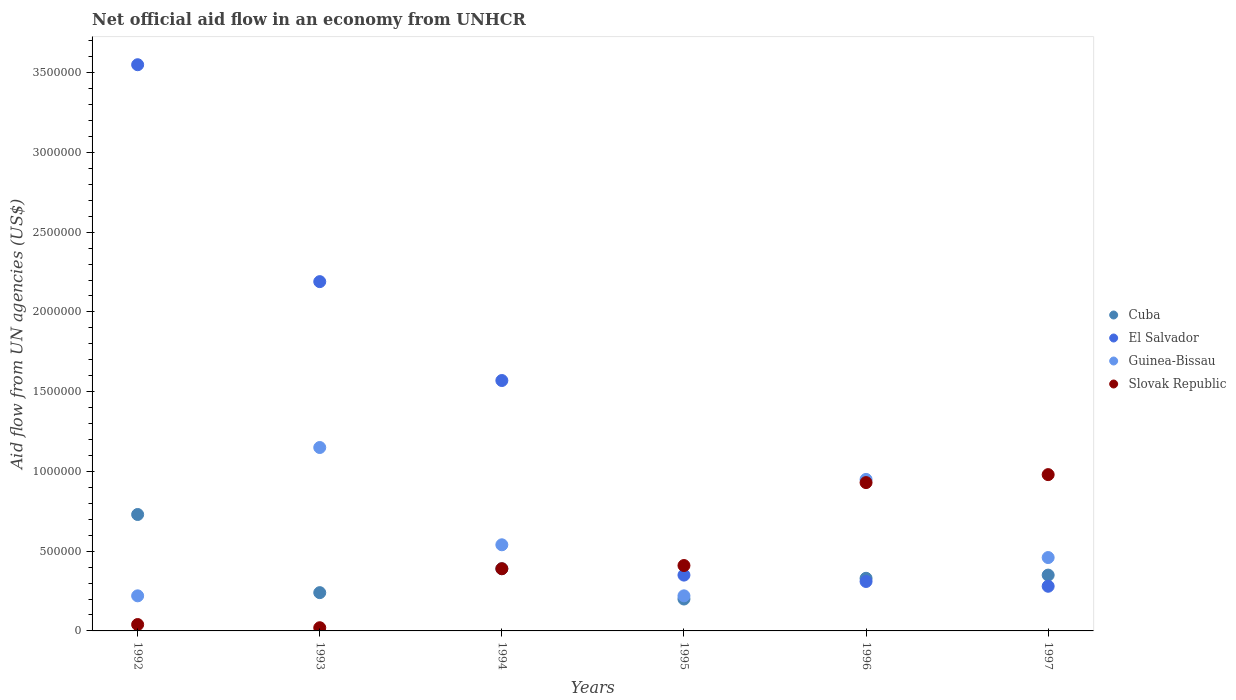Across all years, what is the maximum net official aid flow in Slovak Republic?
Offer a terse response. 9.80e+05. What is the total net official aid flow in Slovak Republic in the graph?
Your answer should be compact. 2.77e+06. What is the difference between the net official aid flow in Guinea-Bissau in 1992 and the net official aid flow in El Salvador in 1997?
Keep it short and to the point. -6.00e+04. What is the average net official aid flow in El Salvador per year?
Offer a very short reply. 1.38e+06. In the year 1994, what is the difference between the net official aid flow in Cuba and net official aid flow in El Salvador?
Offer a very short reply. -1.18e+06. In how many years, is the net official aid flow in El Salvador greater than 3300000 US$?
Keep it short and to the point. 1. What is the ratio of the net official aid flow in Guinea-Bissau in 1992 to that in 1996?
Provide a short and direct response. 0.23. What is the difference between the highest and the lowest net official aid flow in Cuba?
Provide a short and direct response. 5.30e+05. Does the net official aid flow in Guinea-Bissau monotonically increase over the years?
Offer a terse response. No. Is the net official aid flow in Slovak Republic strictly less than the net official aid flow in Guinea-Bissau over the years?
Your answer should be very brief. No. How many years are there in the graph?
Make the answer very short. 6. Are the values on the major ticks of Y-axis written in scientific E-notation?
Keep it short and to the point. No. Does the graph contain any zero values?
Offer a terse response. No. Where does the legend appear in the graph?
Your response must be concise. Center right. How many legend labels are there?
Your response must be concise. 4. What is the title of the graph?
Ensure brevity in your answer.  Net official aid flow in an economy from UNHCR. Does "Central African Republic" appear as one of the legend labels in the graph?
Offer a very short reply. No. What is the label or title of the Y-axis?
Keep it short and to the point. Aid flow from UN agencies (US$). What is the Aid flow from UN agencies (US$) of Cuba in 1992?
Ensure brevity in your answer.  7.30e+05. What is the Aid flow from UN agencies (US$) of El Salvador in 1992?
Your response must be concise. 3.55e+06. What is the Aid flow from UN agencies (US$) in Guinea-Bissau in 1992?
Give a very brief answer. 2.20e+05. What is the Aid flow from UN agencies (US$) of Slovak Republic in 1992?
Offer a very short reply. 4.00e+04. What is the Aid flow from UN agencies (US$) of El Salvador in 1993?
Your response must be concise. 2.19e+06. What is the Aid flow from UN agencies (US$) in Guinea-Bissau in 1993?
Provide a short and direct response. 1.15e+06. What is the Aid flow from UN agencies (US$) of El Salvador in 1994?
Keep it short and to the point. 1.57e+06. What is the Aid flow from UN agencies (US$) of Guinea-Bissau in 1994?
Provide a short and direct response. 5.40e+05. What is the Aid flow from UN agencies (US$) in Slovak Republic in 1994?
Your answer should be compact. 3.90e+05. What is the Aid flow from UN agencies (US$) in Guinea-Bissau in 1995?
Your answer should be very brief. 2.20e+05. What is the Aid flow from UN agencies (US$) of Guinea-Bissau in 1996?
Provide a succinct answer. 9.50e+05. What is the Aid flow from UN agencies (US$) in Slovak Republic in 1996?
Your answer should be compact. 9.30e+05. What is the Aid flow from UN agencies (US$) of Cuba in 1997?
Your response must be concise. 3.50e+05. What is the Aid flow from UN agencies (US$) in El Salvador in 1997?
Your response must be concise. 2.80e+05. What is the Aid flow from UN agencies (US$) of Slovak Republic in 1997?
Your response must be concise. 9.80e+05. Across all years, what is the maximum Aid flow from UN agencies (US$) of Cuba?
Offer a terse response. 7.30e+05. Across all years, what is the maximum Aid flow from UN agencies (US$) of El Salvador?
Offer a terse response. 3.55e+06. Across all years, what is the maximum Aid flow from UN agencies (US$) of Guinea-Bissau?
Your answer should be compact. 1.15e+06. Across all years, what is the maximum Aid flow from UN agencies (US$) in Slovak Republic?
Offer a very short reply. 9.80e+05. Across all years, what is the minimum Aid flow from UN agencies (US$) in Cuba?
Your response must be concise. 2.00e+05. Across all years, what is the minimum Aid flow from UN agencies (US$) of Slovak Republic?
Offer a very short reply. 2.00e+04. What is the total Aid flow from UN agencies (US$) in Cuba in the graph?
Offer a very short reply. 2.24e+06. What is the total Aid flow from UN agencies (US$) of El Salvador in the graph?
Give a very brief answer. 8.25e+06. What is the total Aid flow from UN agencies (US$) in Guinea-Bissau in the graph?
Provide a succinct answer. 3.54e+06. What is the total Aid flow from UN agencies (US$) in Slovak Republic in the graph?
Provide a short and direct response. 2.77e+06. What is the difference between the Aid flow from UN agencies (US$) of Cuba in 1992 and that in 1993?
Your answer should be compact. 4.90e+05. What is the difference between the Aid flow from UN agencies (US$) of El Salvador in 1992 and that in 1993?
Provide a succinct answer. 1.36e+06. What is the difference between the Aid flow from UN agencies (US$) of Guinea-Bissau in 1992 and that in 1993?
Offer a very short reply. -9.30e+05. What is the difference between the Aid flow from UN agencies (US$) of Slovak Republic in 1992 and that in 1993?
Your response must be concise. 2.00e+04. What is the difference between the Aid flow from UN agencies (US$) in Cuba in 1992 and that in 1994?
Offer a very short reply. 3.40e+05. What is the difference between the Aid flow from UN agencies (US$) of El Salvador in 1992 and that in 1994?
Offer a terse response. 1.98e+06. What is the difference between the Aid flow from UN agencies (US$) in Guinea-Bissau in 1992 and that in 1994?
Provide a succinct answer. -3.20e+05. What is the difference between the Aid flow from UN agencies (US$) in Slovak Republic in 1992 and that in 1994?
Make the answer very short. -3.50e+05. What is the difference between the Aid flow from UN agencies (US$) of Cuba in 1992 and that in 1995?
Offer a terse response. 5.30e+05. What is the difference between the Aid flow from UN agencies (US$) in El Salvador in 1992 and that in 1995?
Your answer should be very brief. 3.20e+06. What is the difference between the Aid flow from UN agencies (US$) of Guinea-Bissau in 1992 and that in 1995?
Provide a succinct answer. 0. What is the difference between the Aid flow from UN agencies (US$) in Slovak Republic in 1992 and that in 1995?
Make the answer very short. -3.70e+05. What is the difference between the Aid flow from UN agencies (US$) in El Salvador in 1992 and that in 1996?
Make the answer very short. 3.24e+06. What is the difference between the Aid flow from UN agencies (US$) in Guinea-Bissau in 1992 and that in 1996?
Your response must be concise. -7.30e+05. What is the difference between the Aid flow from UN agencies (US$) of Slovak Republic in 1992 and that in 1996?
Provide a succinct answer. -8.90e+05. What is the difference between the Aid flow from UN agencies (US$) in El Salvador in 1992 and that in 1997?
Your response must be concise. 3.27e+06. What is the difference between the Aid flow from UN agencies (US$) of Guinea-Bissau in 1992 and that in 1997?
Offer a terse response. -2.40e+05. What is the difference between the Aid flow from UN agencies (US$) of Slovak Republic in 1992 and that in 1997?
Offer a terse response. -9.40e+05. What is the difference between the Aid flow from UN agencies (US$) of El Salvador in 1993 and that in 1994?
Provide a succinct answer. 6.20e+05. What is the difference between the Aid flow from UN agencies (US$) in Slovak Republic in 1993 and that in 1994?
Your answer should be compact. -3.70e+05. What is the difference between the Aid flow from UN agencies (US$) in Cuba in 1993 and that in 1995?
Your answer should be compact. 4.00e+04. What is the difference between the Aid flow from UN agencies (US$) of El Salvador in 1993 and that in 1995?
Ensure brevity in your answer.  1.84e+06. What is the difference between the Aid flow from UN agencies (US$) of Guinea-Bissau in 1993 and that in 1995?
Ensure brevity in your answer.  9.30e+05. What is the difference between the Aid flow from UN agencies (US$) in Slovak Republic in 1993 and that in 1995?
Give a very brief answer. -3.90e+05. What is the difference between the Aid flow from UN agencies (US$) of El Salvador in 1993 and that in 1996?
Give a very brief answer. 1.88e+06. What is the difference between the Aid flow from UN agencies (US$) in Slovak Republic in 1993 and that in 1996?
Provide a short and direct response. -9.10e+05. What is the difference between the Aid flow from UN agencies (US$) in El Salvador in 1993 and that in 1997?
Offer a very short reply. 1.91e+06. What is the difference between the Aid flow from UN agencies (US$) of Guinea-Bissau in 1993 and that in 1997?
Your response must be concise. 6.90e+05. What is the difference between the Aid flow from UN agencies (US$) of Slovak Republic in 1993 and that in 1997?
Ensure brevity in your answer.  -9.60e+05. What is the difference between the Aid flow from UN agencies (US$) of Cuba in 1994 and that in 1995?
Offer a terse response. 1.90e+05. What is the difference between the Aid flow from UN agencies (US$) in El Salvador in 1994 and that in 1995?
Give a very brief answer. 1.22e+06. What is the difference between the Aid flow from UN agencies (US$) in Guinea-Bissau in 1994 and that in 1995?
Provide a short and direct response. 3.20e+05. What is the difference between the Aid flow from UN agencies (US$) in Slovak Republic in 1994 and that in 1995?
Make the answer very short. -2.00e+04. What is the difference between the Aid flow from UN agencies (US$) in Cuba in 1994 and that in 1996?
Your answer should be very brief. 6.00e+04. What is the difference between the Aid flow from UN agencies (US$) of El Salvador in 1994 and that in 1996?
Your answer should be compact. 1.26e+06. What is the difference between the Aid flow from UN agencies (US$) of Guinea-Bissau in 1994 and that in 1996?
Keep it short and to the point. -4.10e+05. What is the difference between the Aid flow from UN agencies (US$) of Slovak Republic in 1994 and that in 1996?
Your answer should be compact. -5.40e+05. What is the difference between the Aid flow from UN agencies (US$) of El Salvador in 1994 and that in 1997?
Provide a short and direct response. 1.29e+06. What is the difference between the Aid flow from UN agencies (US$) of Guinea-Bissau in 1994 and that in 1997?
Offer a very short reply. 8.00e+04. What is the difference between the Aid flow from UN agencies (US$) in Slovak Republic in 1994 and that in 1997?
Provide a succinct answer. -5.90e+05. What is the difference between the Aid flow from UN agencies (US$) in Guinea-Bissau in 1995 and that in 1996?
Provide a succinct answer. -7.30e+05. What is the difference between the Aid flow from UN agencies (US$) of Slovak Republic in 1995 and that in 1996?
Offer a very short reply. -5.20e+05. What is the difference between the Aid flow from UN agencies (US$) in Cuba in 1995 and that in 1997?
Your answer should be compact. -1.50e+05. What is the difference between the Aid flow from UN agencies (US$) of Slovak Republic in 1995 and that in 1997?
Keep it short and to the point. -5.70e+05. What is the difference between the Aid flow from UN agencies (US$) of El Salvador in 1996 and that in 1997?
Your answer should be compact. 3.00e+04. What is the difference between the Aid flow from UN agencies (US$) in Cuba in 1992 and the Aid flow from UN agencies (US$) in El Salvador in 1993?
Keep it short and to the point. -1.46e+06. What is the difference between the Aid flow from UN agencies (US$) of Cuba in 1992 and the Aid flow from UN agencies (US$) of Guinea-Bissau in 1993?
Keep it short and to the point. -4.20e+05. What is the difference between the Aid flow from UN agencies (US$) of Cuba in 1992 and the Aid flow from UN agencies (US$) of Slovak Republic in 1993?
Make the answer very short. 7.10e+05. What is the difference between the Aid flow from UN agencies (US$) in El Salvador in 1992 and the Aid flow from UN agencies (US$) in Guinea-Bissau in 1993?
Your answer should be compact. 2.40e+06. What is the difference between the Aid flow from UN agencies (US$) of El Salvador in 1992 and the Aid flow from UN agencies (US$) of Slovak Republic in 1993?
Offer a terse response. 3.53e+06. What is the difference between the Aid flow from UN agencies (US$) in Guinea-Bissau in 1992 and the Aid flow from UN agencies (US$) in Slovak Republic in 1993?
Your answer should be very brief. 2.00e+05. What is the difference between the Aid flow from UN agencies (US$) of Cuba in 1992 and the Aid flow from UN agencies (US$) of El Salvador in 1994?
Your answer should be compact. -8.40e+05. What is the difference between the Aid flow from UN agencies (US$) of Cuba in 1992 and the Aid flow from UN agencies (US$) of Guinea-Bissau in 1994?
Make the answer very short. 1.90e+05. What is the difference between the Aid flow from UN agencies (US$) in Cuba in 1992 and the Aid flow from UN agencies (US$) in Slovak Republic in 1994?
Your answer should be very brief. 3.40e+05. What is the difference between the Aid flow from UN agencies (US$) in El Salvador in 1992 and the Aid flow from UN agencies (US$) in Guinea-Bissau in 1994?
Offer a terse response. 3.01e+06. What is the difference between the Aid flow from UN agencies (US$) in El Salvador in 1992 and the Aid flow from UN agencies (US$) in Slovak Republic in 1994?
Provide a succinct answer. 3.16e+06. What is the difference between the Aid flow from UN agencies (US$) of Cuba in 1992 and the Aid flow from UN agencies (US$) of Guinea-Bissau in 1995?
Your answer should be compact. 5.10e+05. What is the difference between the Aid flow from UN agencies (US$) of El Salvador in 1992 and the Aid flow from UN agencies (US$) of Guinea-Bissau in 1995?
Ensure brevity in your answer.  3.33e+06. What is the difference between the Aid flow from UN agencies (US$) in El Salvador in 1992 and the Aid flow from UN agencies (US$) in Slovak Republic in 1995?
Make the answer very short. 3.14e+06. What is the difference between the Aid flow from UN agencies (US$) in Cuba in 1992 and the Aid flow from UN agencies (US$) in Guinea-Bissau in 1996?
Ensure brevity in your answer.  -2.20e+05. What is the difference between the Aid flow from UN agencies (US$) of Cuba in 1992 and the Aid flow from UN agencies (US$) of Slovak Republic in 1996?
Your answer should be compact. -2.00e+05. What is the difference between the Aid flow from UN agencies (US$) in El Salvador in 1992 and the Aid flow from UN agencies (US$) in Guinea-Bissau in 1996?
Provide a succinct answer. 2.60e+06. What is the difference between the Aid flow from UN agencies (US$) of El Salvador in 1992 and the Aid flow from UN agencies (US$) of Slovak Republic in 1996?
Offer a very short reply. 2.62e+06. What is the difference between the Aid flow from UN agencies (US$) in Guinea-Bissau in 1992 and the Aid flow from UN agencies (US$) in Slovak Republic in 1996?
Provide a short and direct response. -7.10e+05. What is the difference between the Aid flow from UN agencies (US$) of Cuba in 1992 and the Aid flow from UN agencies (US$) of El Salvador in 1997?
Your answer should be very brief. 4.50e+05. What is the difference between the Aid flow from UN agencies (US$) in Cuba in 1992 and the Aid flow from UN agencies (US$) in Guinea-Bissau in 1997?
Offer a terse response. 2.70e+05. What is the difference between the Aid flow from UN agencies (US$) in El Salvador in 1992 and the Aid flow from UN agencies (US$) in Guinea-Bissau in 1997?
Make the answer very short. 3.09e+06. What is the difference between the Aid flow from UN agencies (US$) in El Salvador in 1992 and the Aid flow from UN agencies (US$) in Slovak Republic in 1997?
Offer a very short reply. 2.57e+06. What is the difference between the Aid flow from UN agencies (US$) of Guinea-Bissau in 1992 and the Aid flow from UN agencies (US$) of Slovak Republic in 1997?
Keep it short and to the point. -7.60e+05. What is the difference between the Aid flow from UN agencies (US$) in Cuba in 1993 and the Aid flow from UN agencies (US$) in El Salvador in 1994?
Provide a succinct answer. -1.33e+06. What is the difference between the Aid flow from UN agencies (US$) in Cuba in 1993 and the Aid flow from UN agencies (US$) in Guinea-Bissau in 1994?
Ensure brevity in your answer.  -3.00e+05. What is the difference between the Aid flow from UN agencies (US$) of El Salvador in 1993 and the Aid flow from UN agencies (US$) of Guinea-Bissau in 1994?
Keep it short and to the point. 1.65e+06. What is the difference between the Aid flow from UN agencies (US$) in El Salvador in 1993 and the Aid flow from UN agencies (US$) in Slovak Republic in 1994?
Ensure brevity in your answer.  1.80e+06. What is the difference between the Aid flow from UN agencies (US$) of Guinea-Bissau in 1993 and the Aid flow from UN agencies (US$) of Slovak Republic in 1994?
Your answer should be compact. 7.60e+05. What is the difference between the Aid flow from UN agencies (US$) in Cuba in 1993 and the Aid flow from UN agencies (US$) in El Salvador in 1995?
Keep it short and to the point. -1.10e+05. What is the difference between the Aid flow from UN agencies (US$) in Cuba in 1993 and the Aid flow from UN agencies (US$) in Guinea-Bissau in 1995?
Your response must be concise. 2.00e+04. What is the difference between the Aid flow from UN agencies (US$) of El Salvador in 1993 and the Aid flow from UN agencies (US$) of Guinea-Bissau in 1995?
Keep it short and to the point. 1.97e+06. What is the difference between the Aid flow from UN agencies (US$) of El Salvador in 1993 and the Aid flow from UN agencies (US$) of Slovak Republic in 1995?
Your answer should be very brief. 1.78e+06. What is the difference between the Aid flow from UN agencies (US$) in Guinea-Bissau in 1993 and the Aid flow from UN agencies (US$) in Slovak Republic in 1995?
Give a very brief answer. 7.40e+05. What is the difference between the Aid flow from UN agencies (US$) of Cuba in 1993 and the Aid flow from UN agencies (US$) of Guinea-Bissau in 1996?
Give a very brief answer. -7.10e+05. What is the difference between the Aid flow from UN agencies (US$) in Cuba in 1993 and the Aid flow from UN agencies (US$) in Slovak Republic in 1996?
Provide a short and direct response. -6.90e+05. What is the difference between the Aid flow from UN agencies (US$) of El Salvador in 1993 and the Aid flow from UN agencies (US$) of Guinea-Bissau in 1996?
Your answer should be very brief. 1.24e+06. What is the difference between the Aid flow from UN agencies (US$) in El Salvador in 1993 and the Aid flow from UN agencies (US$) in Slovak Republic in 1996?
Keep it short and to the point. 1.26e+06. What is the difference between the Aid flow from UN agencies (US$) of Cuba in 1993 and the Aid flow from UN agencies (US$) of Guinea-Bissau in 1997?
Keep it short and to the point. -2.20e+05. What is the difference between the Aid flow from UN agencies (US$) of Cuba in 1993 and the Aid flow from UN agencies (US$) of Slovak Republic in 1997?
Make the answer very short. -7.40e+05. What is the difference between the Aid flow from UN agencies (US$) in El Salvador in 1993 and the Aid flow from UN agencies (US$) in Guinea-Bissau in 1997?
Provide a short and direct response. 1.73e+06. What is the difference between the Aid flow from UN agencies (US$) in El Salvador in 1993 and the Aid flow from UN agencies (US$) in Slovak Republic in 1997?
Offer a terse response. 1.21e+06. What is the difference between the Aid flow from UN agencies (US$) of Cuba in 1994 and the Aid flow from UN agencies (US$) of El Salvador in 1995?
Provide a succinct answer. 4.00e+04. What is the difference between the Aid flow from UN agencies (US$) of Cuba in 1994 and the Aid flow from UN agencies (US$) of Slovak Republic in 1995?
Give a very brief answer. -2.00e+04. What is the difference between the Aid flow from UN agencies (US$) of El Salvador in 1994 and the Aid flow from UN agencies (US$) of Guinea-Bissau in 1995?
Give a very brief answer. 1.35e+06. What is the difference between the Aid flow from UN agencies (US$) in El Salvador in 1994 and the Aid flow from UN agencies (US$) in Slovak Republic in 1995?
Offer a very short reply. 1.16e+06. What is the difference between the Aid flow from UN agencies (US$) in Cuba in 1994 and the Aid flow from UN agencies (US$) in El Salvador in 1996?
Offer a terse response. 8.00e+04. What is the difference between the Aid flow from UN agencies (US$) of Cuba in 1994 and the Aid flow from UN agencies (US$) of Guinea-Bissau in 1996?
Offer a terse response. -5.60e+05. What is the difference between the Aid flow from UN agencies (US$) of Cuba in 1994 and the Aid flow from UN agencies (US$) of Slovak Republic in 1996?
Your answer should be very brief. -5.40e+05. What is the difference between the Aid flow from UN agencies (US$) of El Salvador in 1994 and the Aid flow from UN agencies (US$) of Guinea-Bissau in 1996?
Provide a short and direct response. 6.20e+05. What is the difference between the Aid flow from UN agencies (US$) in El Salvador in 1994 and the Aid flow from UN agencies (US$) in Slovak Republic in 1996?
Provide a short and direct response. 6.40e+05. What is the difference between the Aid flow from UN agencies (US$) of Guinea-Bissau in 1994 and the Aid flow from UN agencies (US$) of Slovak Republic in 1996?
Your answer should be very brief. -3.90e+05. What is the difference between the Aid flow from UN agencies (US$) in Cuba in 1994 and the Aid flow from UN agencies (US$) in Slovak Republic in 1997?
Provide a short and direct response. -5.90e+05. What is the difference between the Aid flow from UN agencies (US$) of El Salvador in 1994 and the Aid flow from UN agencies (US$) of Guinea-Bissau in 1997?
Your answer should be very brief. 1.11e+06. What is the difference between the Aid flow from UN agencies (US$) of El Salvador in 1994 and the Aid flow from UN agencies (US$) of Slovak Republic in 1997?
Your answer should be compact. 5.90e+05. What is the difference between the Aid flow from UN agencies (US$) in Guinea-Bissau in 1994 and the Aid flow from UN agencies (US$) in Slovak Republic in 1997?
Provide a succinct answer. -4.40e+05. What is the difference between the Aid flow from UN agencies (US$) of Cuba in 1995 and the Aid flow from UN agencies (US$) of El Salvador in 1996?
Your response must be concise. -1.10e+05. What is the difference between the Aid flow from UN agencies (US$) in Cuba in 1995 and the Aid flow from UN agencies (US$) in Guinea-Bissau in 1996?
Your response must be concise. -7.50e+05. What is the difference between the Aid flow from UN agencies (US$) in Cuba in 1995 and the Aid flow from UN agencies (US$) in Slovak Republic in 1996?
Your answer should be very brief. -7.30e+05. What is the difference between the Aid flow from UN agencies (US$) of El Salvador in 1995 and the Aid flow from UN agencies (US$) of Guinea-Bissau in 1996?
Your answer should be very brief. -6.00e+05. What is the difference between the Aid flow from UN agencies (US$) in El Salvador in 1995 and the Aid flow from UN agencies (US$) in Slovak Republic in 1996?
Keep it short and to the point. -5.80e+05. What is the difference between the Aid flow from UN agencies (US$) of Guinea-Bissau in 1995 and the Aid flow from UN agencies (US$) of Slovak Republic in 1996?
Offer a very short reply. -7.10e+05. What is the difference between the Aid flow from UN agencies (US$) in Cuba in 1995 and the Aid flow from UN agencies (US$) in Guinea-Bissau in 1997?
Ensure brevity in your answer.  -2.60e+05. What is the difference between the Aid flow from UN agencies (US$) in Cuba in 1995 and the Aid flow from UN agencies (US$) in Slovak Republic in 1997?
Keep it short and to the point. -7.80e+05. What is the difference between the Aid flow from UN agencies (US$) in El Salvador in 1995 and the Aid flow from UN agencies (US$) in Slovak Republic in 1997?
Your answer should be very brief. -6.30e+05. What is the difference between the Aid flow from UN agencies (US$) in Guinea-Bissau in 1995 and the Aid flow from UN agencies (US$) in Slovak Republic in 1997?
Offer a very short reply. -7.60e+05. What is the difference between the Aid flow from UN agencies (US$) of Cuba in 1996 and the Aid flow from UN agencies (US$) of Slovak Republic in 1997?
Ensure brevity in your answer.  -6.50e+05. What is the difference between the Aid flow from UN agencies (US$) in El Salvador in 1996 and the Aid flow from UN agencies (US$) in Slovak Republic in 1997?
Ensure brevity in your answer.  -6.70e+05. What is the average Aid flow from UN agencies (US$) in Cuba per year?
Give a very brief answer. 3.73e+05. What is the average Aid flow from UN agencies (US$) of El Salvador per year?
Your response must be concise. 1.38e+06. What is the average Aid flow from UN agencies (US$) of Guinea-Bissau per year?
Keep it short and to the point. 5.90e+05. What is the average Aid flow from UN agencies (US$) of Slovak Republic per year?
Give a very brief answer. 4.62e+05. In the year 1992, what is the difference between the Aid flow from UN agencies (US$) of Cuba and Aid flow from UN agencies (US$) of El Salvador?
Keep it short and to the point. -2.82e+06. In the year 1992, what is the difference between the Aid flow from UN agencies (US$) of Cuba and Aid flow from UN agencies (US$) of Guinea-Bissau?
Offer a very short reply. 5.10e+05. In the year 1992, what is the difference between the Aid flow from UN agencies (US$) in Cuba and Aid flow from UN agencies (US$) in Slovak Republic?
Provide a short and direct response. 6.90e+05. In the year 1992, what is the difference between the Aid flow from UN agencies (US$) of El Salvador and Aid flow from UN agencies (US$) of Guinea-Bissau?
Keep it short and to the point. 3.33e+06. In the year 1992, what is the difference between the Aid flow from UN agencies (US$) of El Salvador and Aid flow from UN agencies (US$) of Slovak Republic?
Provide a short and direct response. 3.51e+06. In the year 1993, what is the difference between the Aid flow from UN agencies (US$) in Cuba and Aid flow from UN agencies (US$) in El Salvador?
Your answer should be compact. -1.95e+06. In the year 1993, what is the difference between the Aid flow from UN agencies (US$) in Cuba and Aid flow from UN agencies (US$) in Guinea-Bissau?
Provide a short and direct response. -9.10e+05. In the year 1993, what is the difference between the Aid flow from UN agencies (US$) in Cuba and Aid flow from UN agencies (US$) in Slovak Republic?
Provide a short and direct response. 2.20e+05. In the year 1993, what is the difference between the Aid flow from UN agencies (US$) of El Salvador and Aid flow from UN agencies (US$) of Guinea-Bissau?
Make the answer very short. 1.04e+06. In the year 1993, what is the difference between the Aid flow from UN agencies (US$) in El Salvador and Aid flow from UN agencies (US$) in Slovak Republic?
Offer a very short reply. 2.17e+06. In the year 1993, what is the difference between the Aid flow from UN agencies (US$) in Guinea-Bissau and Aid flow from UN agencies (US$) in Slovak Republic?
Keep it short and to the point. 1.13e+06. In the year 1994, what is the difference between the Aid flow from UN agencies (US$) of Cuba and Aid flow from UN agencies (US$) of El Salvador?
Offer a very short reply. -1.18e+06. In the year 1994, what is the difference between the Aid flow from UN agencies (US$) of Cuba and Aid flow from UN agencies (US$) of Slovak Republic?
Your answer should be compact. 0. In the year 1994, what is the difference between the Aid flow from UN agencies (US$) of El Salvador and Aid flow from UN agencies (US$) of Guinea-Bissau?
Provide a short and direct response. 1.03e+06. In the year 1994, what is the difference between the Aid flow from UN agencies (US$) of El Salvador and Aid flow from UN agencies (US$) of Slovak Republic?
Provide a succinct answer. 1.18e+06. In the year 1994, what is the difference between the Aid flow from UN agencies (US$) in Guinea-Bissau and Aid flow from UN agencies (US$) in Slovak Republic?
Keep it short and to the point. 1.50e+05. In the year 1995, what is the difference between the Aid flow from UN agencies (US$) in Cuba and Aid flow from UN agencies (US$) in Guinea-Bissau?
Your answer should be very brief. -2.00e+04. In the year 1995, what is the difference between the Aid flow from UN agencies (US$) of Guinea-Bissau and Aid flow from UN agencies (US$) of Slovak Republic?
Keep it short and to the point. -1.90e+05. In the year 1996, what is the difference between the Aid flow from UN agencies (US$) in Cuba and Aid flow from UN agencies (US$) in Guinea-Bissau?
Offer a very short reply. -6.20e+05. In the year 1996, what is the difference between the Aid flow from UN agencies (US$) in Cuba and Aid flow from UN agencies (US$) in Slovak Republic?
Provide a succinct answer. -6.00e+05. In the year 1996, what is the difference between the Aid flow from UN agencies (US$) in El Salvador and Aid flow from UN agencies (US$) in Guinea-Bissau?
Give a very brief answer. -6.40e+05. In the year 1996, what is the difference between the Aid flow from UN agencies (US$) in El Salvador and Aid flow from UN agencies (US$) in Slovak Republic?
Your response must be concise. -6.20e+05. In the year 1997, what is the difference between the Aid flow from UN agencies (US$) in Cuba and Aid flow from UN agencies (US$) in Guinea-Bissau?
Ensure brevity in your answer.  -1.10e+05. In the year 1997, what is the difference between the Aid flow from UN agencies (US$) in Cuba and Aid flow from UN agencies (US$) in Slovak Republic?
Offer a very short reply. -6.30e+05. In the year 1997, what is the difference between the Aid flow from UN agencies (US$) in El Salvador and Aid flow from UN agencies (US$) in Guinea-Bissau?
Provide a succinct answer. -1.80e+05. In the year 1997, what is the difference between the Aid flow from UN agencies (US$) of El Salvador and Aid flow from UN agencies (US$) of Slovak Republic?
Offer a terse response. -7.00e+05. In the year 1997, what is the difference between the Aid flow from UN agencies (US$) of Guinea-Bissau and Aid flow from UN agencies (US$) of Slovak Republic?
Make the answer very short. -5.20e+05. What is the ratio of the Aid flow from UN agencies (US$) in Cuba in 1992 to that in 1993?
Ensure brevity in your answer.  3.04. What is the ratio of the Aid flow from UN agencies (US$) of El Salvador in 1992 to that in 1993?
Offer a terse response. 1.62. What is the ratio of the Aid flow from UN agencies (US$) in Guinea-Bissau in 1992 to that in 1993?
Your answer should be very brief. 0.19. What is the ratio of the Aid flow from UN agencies (US$) of Cuba in 1992 to that in 1994?
Make the answer very short. 1.87. What is the ratio of the Aid flow from UN agencies (US$) in El Salvador in 1992 to that in 1994?
Provide a short and direct response. 2.26. What is the ratio of the Aid flow from UN agencies (US$) of Guinea-Bissau in 1992 to that in 1994?
Your answer should be compact. 0.41. What is the ratio of the Aid flow from UN agencies (US$) in Slovak Republic in 1992 to that in 1994?
Give a very brief answer. 0.1. What is the ratio of the Aid flow from UN agencies (US$) of Cuba in 1992 to that in 1995?
Ensure brevity in your answer.  3.65. What is the ratio of the Aid flow from UN agencies (US$) of El Salvador in 1992 to that in 1995?
Ensure brevity in your answer.  10.14. What is the ratio of the Aid flow from UN agencies (US$) in Guinea-Bissau in 1992 to that in 1995?
Make the answer very short. 1. What is the ratio of the Aid flow from UN agencies (US$) of Slovak Republic in 1992 to that in 1995?
Give a very brief answer. 0.1. What is the ratio of the Aid flow from UN agencies (US$) in Cuba in 1992 to that in 1996?
Offer a very short reply. 2.21. What is the ratio of the Aid flow from UN agencies (US$) of El Salvador in 1992 to that in 1996?
Offer a very short reply. 11.45. What is the ratio of the Aid flow from UN agencies (US$) in Guinea-Bissau in 1992 to that in 1996?
Provide a succinct answer. 0.23. What is the ratio of the Aid flow from UN agencies (US$) in Slovak Republic in 1992 to that in 1996?
Provide a short and direct response. 0.04. What is the ratio of the Aid flow from UN agencies (US$) in Cuba in 1992 to that in 1997?
Offer a very short reply. 2.09. What is the ratio of the Aid flow from UN agencies (US$) of El Salvador in 1992 to that in 1997?
Provide a short and direct response. 12.68. What is the ratio of the Aid flow from UN agencies (US$) in Guinea-Bissau in 1992 to that in 1997?
Give a very brief answer. 0.48. What is the ratio of the Aid flow from UN agencies (US$) in Slovak Republic in 1992 to that in 1997?
Provide a short and direct response. 0.04. What is the ratio of the Aid flow from UN agencies (US$) of Cuba in 1993 to that in 1994?
Your response must be concise. 0.62. What is the ratio of the Aid flow from UN agencies (US$) of El Salvador in 1993 to that in 1994?
Provide a short and direct response. 1.39. What is the ratio of the Aid flow from UN agencies (US$) of Guinea-Bissau in 1993 to that in 1994?
Keep it short and to the point. 2.13. What is the ratio of the Aid flow from UN agencies (US$) of Slovak Republic in 1993 to that in 1994?
Your answer should be compact. 0.05. What is the ratio of the Aid flow from UN agencies (US$) in El Salvador in 1993 to that in 1995?
Ensure brevity in your answer.  6.26. What is the ratio of the Aid flow from UN agencies (US$) in Guinea-Bissau in 1993 to that in 1995?
Offer a very short reply. 5.23. What is the ratio of the Aid flow from UN agencies (US$) in Slovak Republic in 1993 to that in 1995?
Your response must be concise. 0.05. What is the ratio of the Aid flow from UN agencies (US$) of Cuba in 1993 to that in 1996?
Offer a terse response. 0.73. What is the ratio of the Aid flow from UN agencies (US$) in El Salvador in 1993 to that in 1996?
Your response must be concise. 7.06. What is the ratio of the Aid flow from UN agencies (US$) in Guinea-Bissau in 1993 to that in 1996?
Offer a very short reply. 1.21. What is the ratio of the Aid flow from UN agencies (US$) of Slovak Republic in 1993 to that in 1996?
Provide a succinct answer. 0.02. What is the ratio of the Aid flow from UN agencies (US$) of Cuba in 1993 to that in 1997?
Keep it short and to the point. 0.69. What is the ratio of the Aid flow from UN agencies (US$) in El Salvador in 1993 to that in 1997?
Give a very brief answer. 7.82. What is the ratio of the Aid flow from UN agencies (US$) of Guinea-Bissau in 1993 to that in 1997?
Make the answer very short. 2.5. What is the ratio of the Aid flow from UN agencies (US$) in Slovak Republic in 1993 to that in 1997?
Give a very brief answer. 0.02. What is the ratio of the Aid flow from UN agencies (US$) of Cuba in 1994 to that in 1995?
Offer a very short reply. 1.95. What is the ratio of the Aid flow from UN agencies (US$) in El Salvador in 1994 to that in 1995?
Your response must be concise. 4.49. What is the ratio of the Aid flow from UN agencies (US$) of Guinea-Bissau in 1994 to that in 1995?
Keep it short and to the point. 2.45. What is the ratio of the Aid flow from UN agencies (US$) of Slovak Republic in 1994 to that in 1995?
Offer a terse response. 0.95. What is the ratio of the Aid flow from UN agencies (US$) in Cuba in 1994 to that in 1996?
Give a very brief answer. 1.18. What is the ratio of the Aid flow from UN agencies (US$) of El Salvador in 1994 to that in 1996?
Your response must be concise. 5.06. What is the ratio of the Aid flow from UN agencies (US$) of Guinea-Bissau in 1994 to that in 1996?
Make the answer very short. 0.57. What is the ratio of the Aid flow from UN agencies (US$) in Slovak Republic in 1994 to that in 1996?
Ensure brevity in your answer.  0.42. What is the ratio of the Aid flow from UN agencies (US$) of Cuba in 1994 to that in 1997?
Provide a succinct answer. 1.11. What is the ratio of the Aid flow from UN agencies (US$) in El Salvador in 1994 to that in 1997?
Keep it short and to the point. 5.61. What is the ratio of the Aid flow from UN agencies (US$) in Guinea-Bissau in 1994 to that in 1997?
Your answer should be compact. 1.17. What is the ratio of the Aid flow from UN agencies (US$) of Slovak Republic in 1994 to that in 1997?
Your answer should be very brief. 0.4. What is the ratio of the Aid flow from UN agencies (US$) in Cuba in 1995 to that in 1996?
Make the answer very short. 0.61. What is the ratio of the Aid flow from UN agencies (US$) in El Salvador in 1995 to that in 1996?
Keep it short and to the point. 1.13. What is the ratio of the Aid flow from UN agencies (US$) of Guinea-Bissau in 1995 to that in 1996?
Provide a succinct answer. 0.23. What is the ratio of the Aid flow from UN agencies (US$) in Slovak Republic in 1995 to that in 1996?
Ensure brevity in your answer.  0.44. What is the ratio of the Aid flow from UN agencies (US$) of El Salvador in 1995 to that in 1997?
Your response must be concise. 1.25. What is the ratio of the Aid flow from UN agencies (US$) in Guinea-Bissau in 1995 to that in 1997?
Your answer should be compact. 0.48. What is the ratio of the Aid flow from UN agencies (US$) of Slovak Republic in 1995 to that in 1997?
Offer a terse response. 0.42. What is the ratio of the Aid flow from UN agencies (US$) in Cuba in 1996 to that in 1997?
Keep it short and to the point. 0.94. What is the ratio of the Aid flow from UN agencies (US$) in El Salvador in 1996 to that in 1997?
Ensure brevity in your answer.  1.11. What is the ratio of the Aid flow from UN agencies (US$) in Guinea-Bissau in 1996 to that in 1997?
Give a very brief answer. 2.07. What is the ratio of the Aid flow from UN agencies (US$) in Slovak Republic in 1996 to that in 1997?
Give a very brief answer. 0.95. What is the difference between the highest and the second highest Aid flow from UN agencies (US$) of Cuba?
Offer a very short reply. 3.40e+05. What is the difference between the highest and the second highest Aid flow from UN agencies (US$) in El Salvador?
Give a very brief answer. 1.36e+06. What is the difference between the highest and the lowest Aid flow from UN agencies (US$) in Cuba?
Your response must be concise. 5.30e+05. What is the difference between the highest and the lowest Aid flow from UN agencies (US$) in El Salvador?
Offer a very short reply. 3.27e+06. What is the difference between the highest and the lowest Aid flow from UN agencies (US$) in Guinea-Bissau?
Keep it short and to the point. 9.30e+05. What is the difference between the highest and the lowest Aid flow from UN agencies (US$) of Slovak Republic?
Your answer should be very brief. 9.60e+05. 